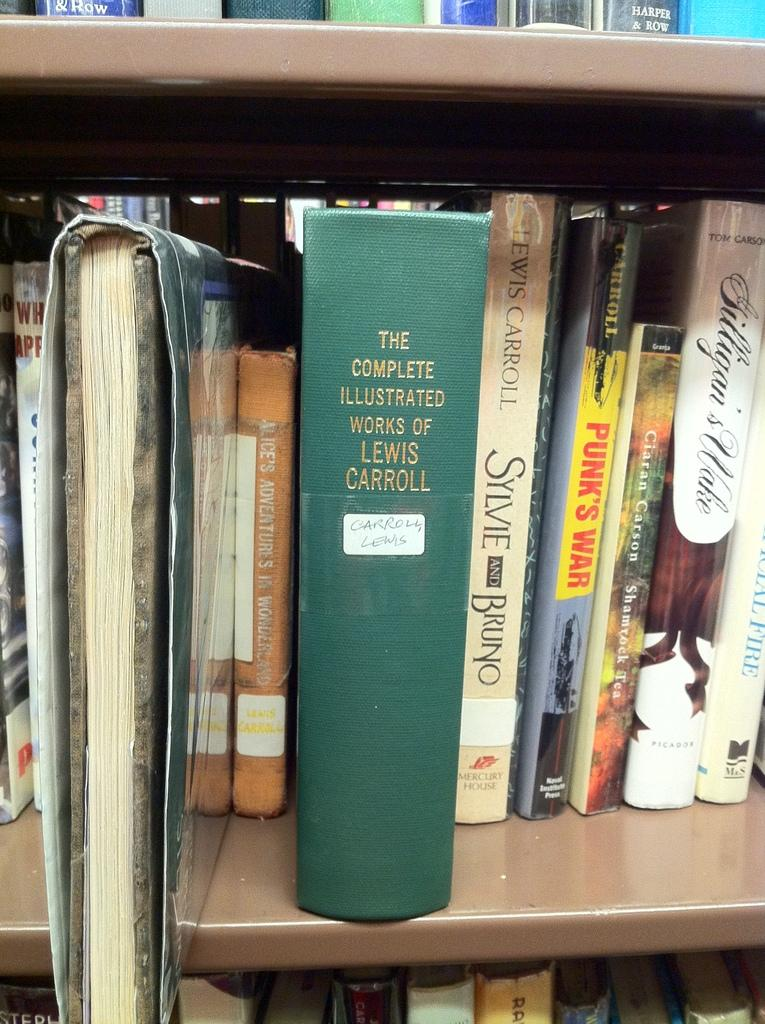<image>
Describe the image concisely. A bookshelf with one particular book standing out which is The complete works of Lewis Carrol. 